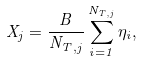Convert formula to latex. <formula><loc_0><loc_0><loc_500><loc_500>X _ { j } = \frac { B } { N _ { T , j } } \sum _ { i = 1 } ^ { N _ { T , j } } \eta _ { i } ,</formula> 